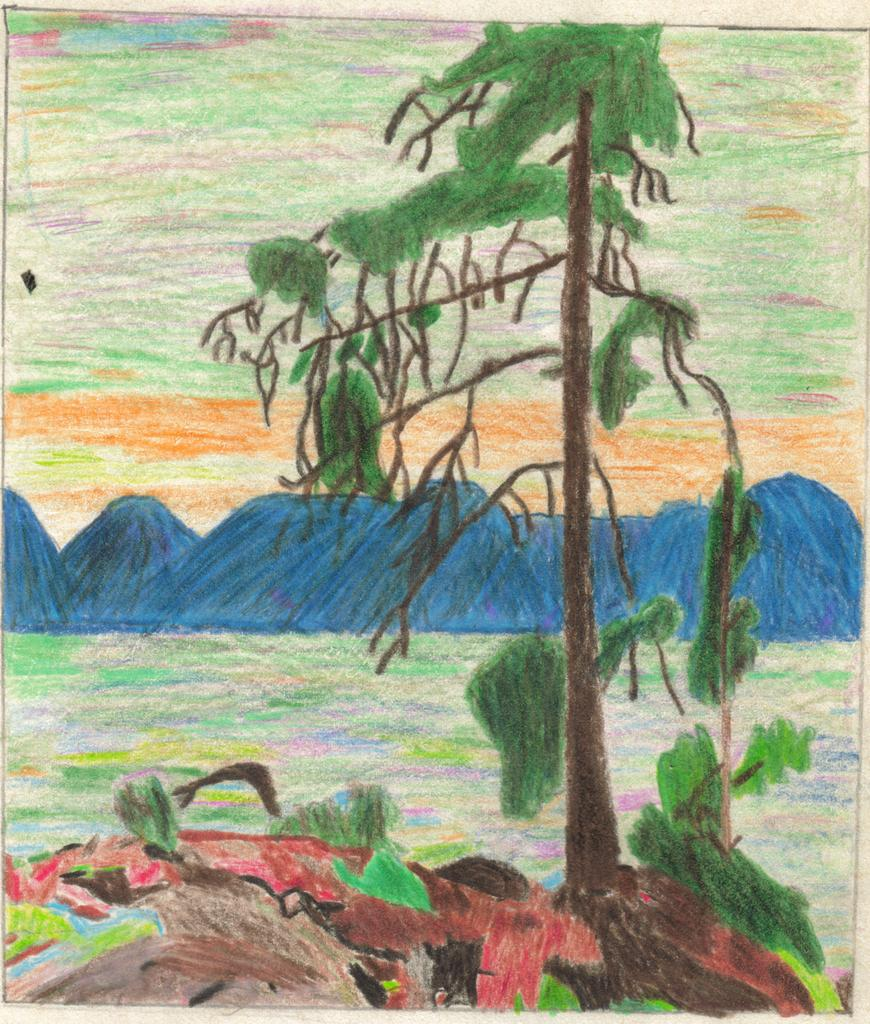What is the main subject of the painting in the image? The painting depicts a tree and mountains. Can you describe the landscape in the painting? The painting depicts a tree and mountains, with the ground visible at the bottom of the painting. What type of humor can be found in the painting? There is no humor present in the painting; it is a depiction of a tree and mountains. 